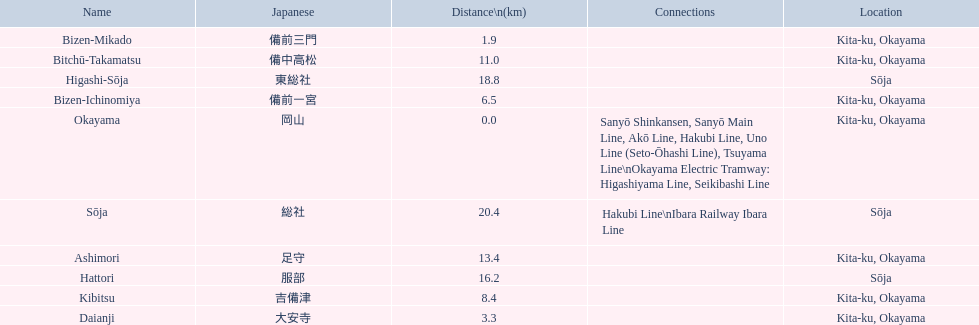Which has the most distance, hattori or kibitsu? Hattori. 